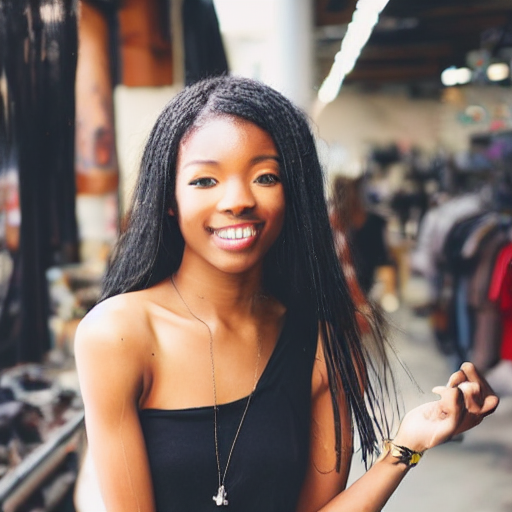Describe the composition of the image.
A. The main subject is obscured.
B. The composition lacks focus.
C. The composition is centered, and the main subject is clearly defined.
Answer with the option's letter from the given choices directly.
 C. 